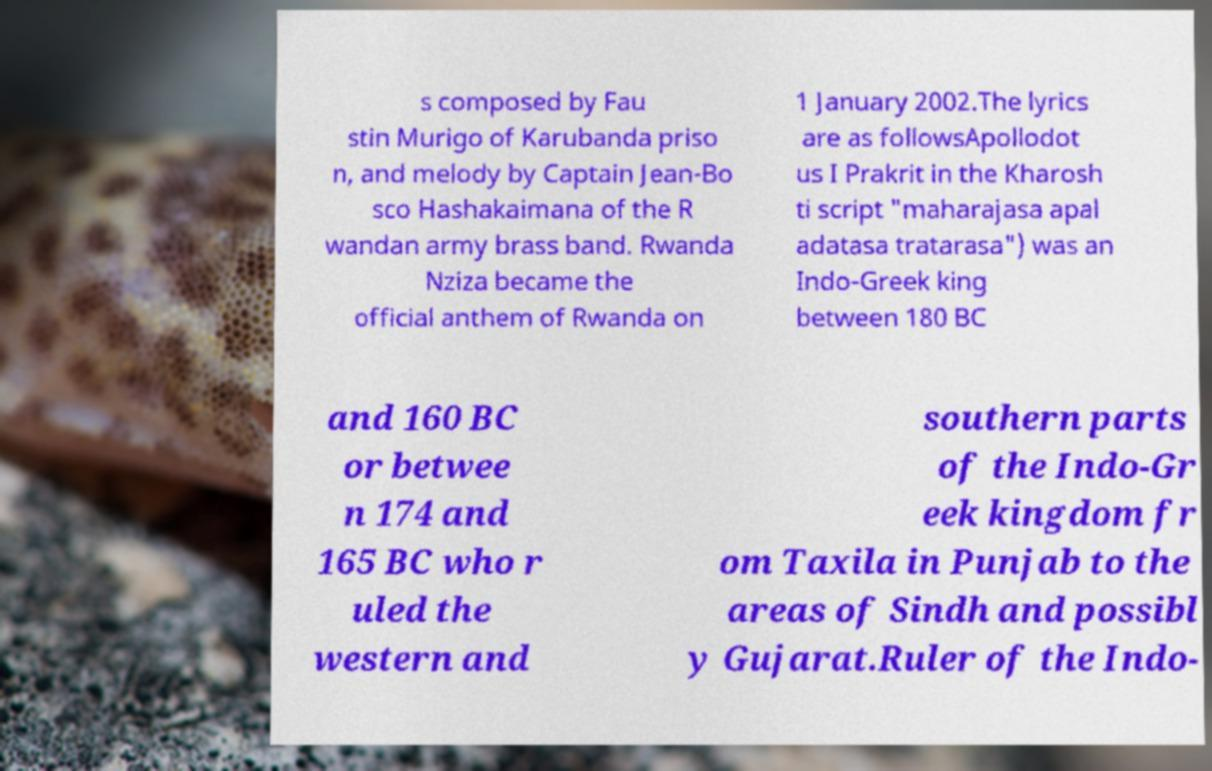Can you read and provide the text displayed in the image?This photo seems to have some interesting text. Can you extract and type it out for me? s composed by Fau stin Murigo of Karubanda priso n, and melody by Captain Jean-Bo sco Hashakaimana of the R wandan army brass band. Rwanda Nziza became the official anthem of Rwanda on 1 January 2002.The lyrics are as followsApollodot us I Prakrit in the Kharosh ti script "maharajasa apal adatasa tratarasa") was an Indo-Greek king between 180 BC and 160 BC or betwee n 174 and 165 BC who r uled the western and southern parts of the Indo-Gr eek kingdom fr om Taxila in Punjab to the areas of Sindh and possibl y Gujarat.Ruler of the Indo- 